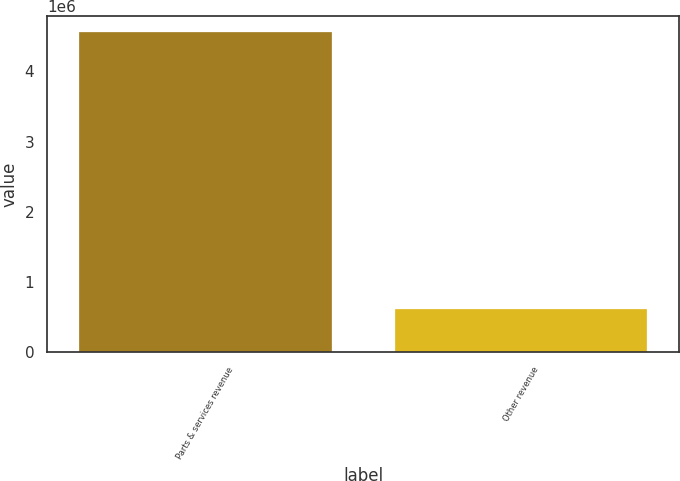Convert chart. <chart><loc_0><loc_0><loc_500><loc_500><bar_chart><fcel>Parts & services revenue<fcel>Other revenue<nl><fcel>4.55822e+06<fcel>623744<nl></chart> 